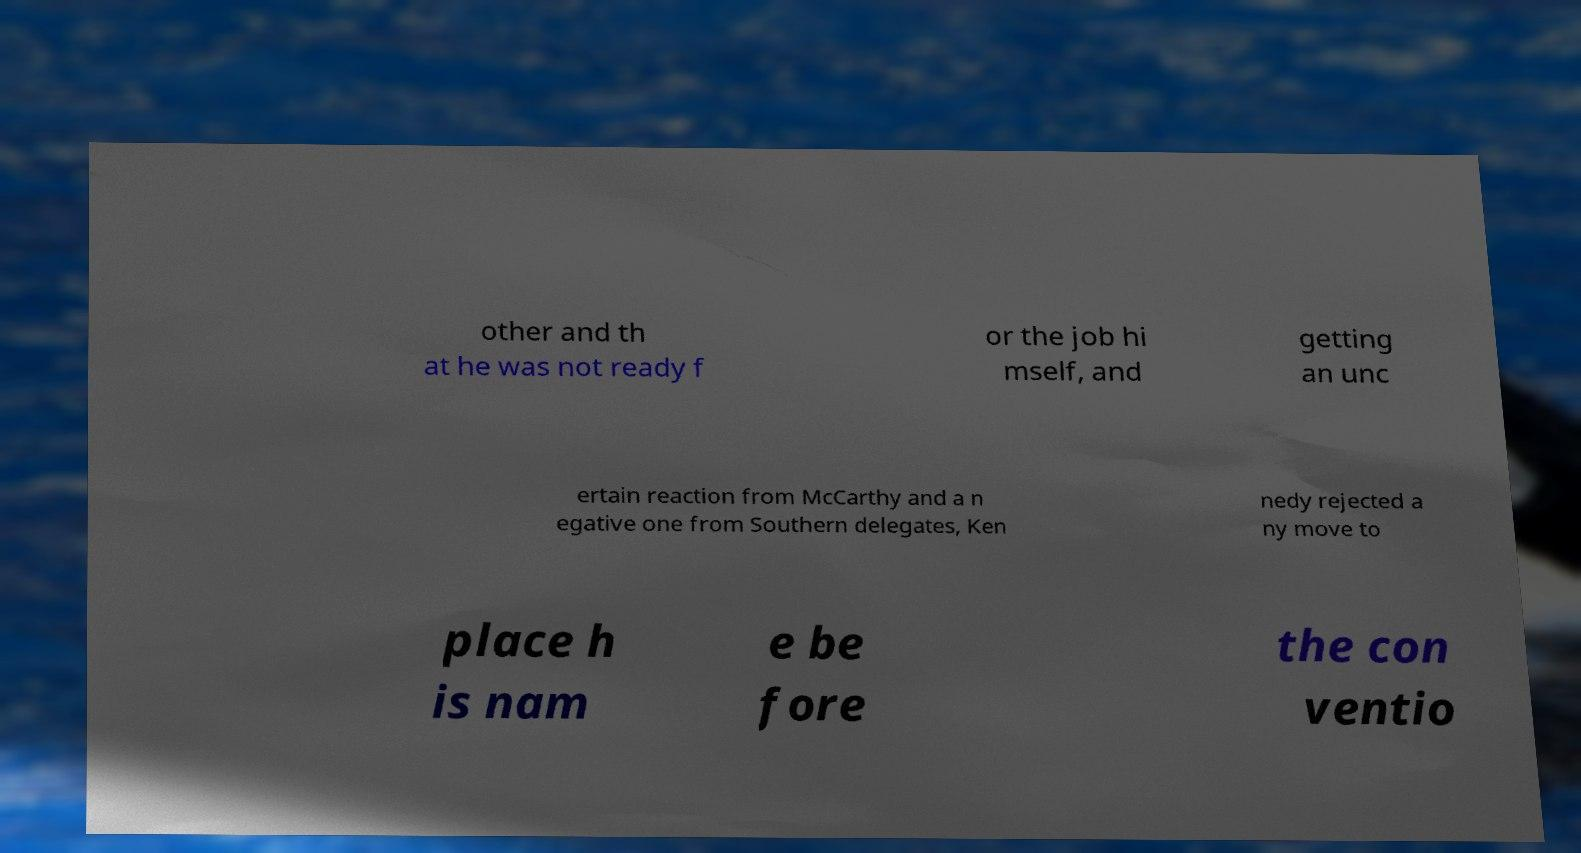I need the written content from this picture converted into text. Can you do that? other and th at he was not ready f or the job hi mself, and getting an unc ertain reaction from McCarthy and a n egative one from Southern delegates, Ken nedy rejected a ny move to place h is nam e be fore the con ventio 